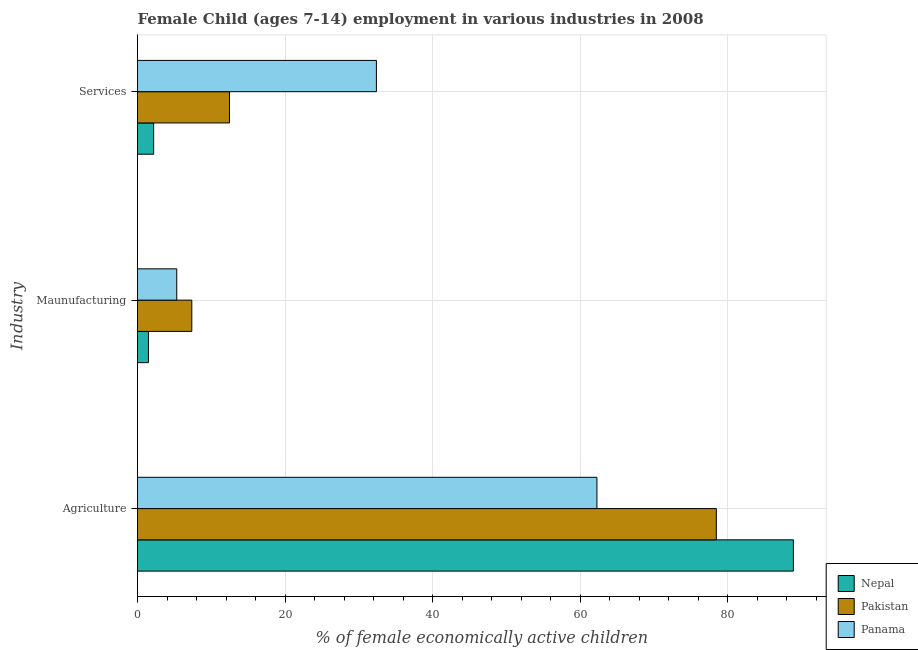How many different coloured bars are there?
Make the answer very short. 3. How many groups of bars are there?
Offer a very short reply. 3. Are the number of bars per tick equal to the number of legend labels?
Ensure brevity in your answer.  Yes. Are the number of bars on each tick of the Y-axis equal?
Give a very brief answer. Yes. How many bars are there on the 1st tick from the top?
Your answer should be very brief. 3. What is the label of the 1st group of bars from the top?
Provide a short and direct response. Services. What is the percentage of economically active children in manufacturing in Pakistan?
Keep it short and to the point. 7.36. Across all countries, what is the maximum percentage of economically active children in manufacturing?
Keep it short and to the point. 7.36. Across all countries, what is the minimum percentage of economically active children in manufacturing?
Give a very brief answer. 1.48. In which country was the percentage of economically active children in services minimum?
Make the answer very short. Nepal. What is the total percentage of economically active children in manufacturing in the graph?
Keep it short and to the point. 14.16. What is the difference between the percentage of economically active children in agriculture in Panama and that in Pakistan?
Offer a very short reply. -16.19. What is the difference between the percentage of economically active children in services in Nepal and the percentage of economically active children in agriculture in Pakistan?
Offer a terse response. -76.29. What is the average percentage of economically active children in services per country?
Offer a very short reply. 15.68. What is the difference between the percentage of economically active children in manufacturing and percentage of economically active children in agriculture in Panama?
Offer a terse response. -56.97. In how many countries, is the percentage of economically active children in manufacturing greater than 24 %?
Offer a very short reply. 0. What is the ratio of the percentage of economically active children in services in Panama to that in Nepal?
Provide a short and direct response. 14.79. Is the percentage of economically active children in agriculture in Pakistan less than that in Nepal?
Make the answer very short. Yes. Is the difference between the percentage of economically active children in services in Nepal and Pakistan greater than the difference between the percentage of economically active children in agriculture in Nepal and Pakistan?
Your response must be concise. No. What is the difference between the highest and the second highest percentage of economically active children in manufacturing?
Make the answer very short. 2.04. What is the difference between the highest and the lowest percentage of economically active children in services?
Your answer should be compact. 30.2. In how many countries, is the percentage of economically active children in services greater than the average percentage of economically active children in services taken over all countries?
Keep it short and to the point. 1. Is the sum of the percentage of economically active children in manufacturing in Panama and Nepal greater than the maximum percentage of economically active children in services across all countries?
Ensure brevity in your answer.  No. What does the 3rd bar from the top in Agriculture represents?
Keep it short and to the point. Nepal. What does the 1st bar from the bottom in Services represents?
Make the answer very short. Nepal. Are all the bars in the graph horizontal?
Offer a terse response. Yes. What is the difference between two consecutive major ticks on the X-axis?
Offer a very short reply. 20. Are the values on the major ticks of X-axis written in scientific E-notation?
Your answer should be very brief. No. Does the graph contain grids?
Your answer should be compact. Yes. What is the title of the graph?
Your response must be concise. Female Child (ages 7-14) employment in various industries in 2008. What is the label or title of the X-axis?
Provide a short and direct response. % of female economically active children. What is the label or title of the Y-axis?
Give a very brief answer. Industry. What is the % of female economically active children of Nepal in Agriculture?
Provide a succinct answer. 88.93. What is the % of female economically active children of Pakistan in Agriculture?
Offer a terse response. 78.48. What is the % of female economically active children in Panama in Agriculture?
Your response must be concise. 62.29. What is the % of female economically active children in Nepal in Maunufacturing?
Your answer should be very brief. 1.48. What is the % of female economically active children in Pakistan in Maunufacturing?
Provide a succinct answer. 7.36. What is the % of female economically active children in Panama in Maunufacturing?
Provide a succinct answer. 5.32. What is the % of female economically active children in Nepal in Services?
Your response must be concise. 2.19. What is the % of female economically active children in Pakistan in Services?
Give a very brief answer. 12.47. What is the % of female economically active children in Panama in Services?
Provide a succinct answer. 32.39. Across all Industry, what is the maximum % of female economically active children of Nepal?
Ensure brevity in your answer.  88.93. Across all Industry, what is the maximum % of female economically active children of Pakistan?
Provide a short and direct response. 78.48. Across all Industry, what is the maximum % of female economically active children in Panama?
Your response must be concise. 62.29. Across all Industry, what is the minimum % of female economically active children of Nepal?
Offer a terse response. 1.48. Across all Industry, what is the minimum % of female economically active children in Pakistan?
Ensure brevity in your answer.  7.36. Across all Industry, what is the minimum % of female economically active children in Panama?
Provide a succinct answer. 5.32. What is the total % of female economically active children of Nepal in the graph?
Make the answer very short. 92.6. What is the total % of female economically active children of Pakistan in the graph?
Ensure brevity in your answer.  98.31. What is the difference between the % of female economically active children of Nepal in Agriculture and that in Maunufacturing?
Ensure brevity in your answer.  87.45. What is the difference between the % of female economically active children in Pakistan in Agriculture and that in Maunufacturing?
Provide a succinct answer. 71.12. What is the difference between the % of female economically active children in Panama in Agriculture and that in Maunufacturing?
Ensure brevity in your answer.  56.97. What is the difference between the % of female economically active children in Nepal in Agriculture and that in Services?
Provide a succinct answer. 86.74. What is the difference between the % of female economically active children of Pakistan in Agriculture and that in Services?
Your answer should be compact. 66.01. What is the difference between the % of female economically active children of Panama in Agriculture and that in Services?
Ensure brevity in your answer.  29.9. What is the difference between the % of female economically active children of Nepal in Maunufacturing and that in Services?
Your answer should be very brief. -0.71. What is the difference between the % of female economically active children in Pakistan in Maunufacturing and that in Services?
Provide a succinct answer. -5.11. What is the difference between the % of female economically active children in Panama in Maunufacturing and that in Services?
Offer a very short reply. -27.07. What is the difference between the % of female economically active children in Nepal in Agriculture and the % of female economically active children in Pakistan in Maunufacturing?
Offer a terse response. 81.57. What is the difference between the % of female economically active children of Nepal in Agriculture and the % of female economically active children of Panama in Maunufacturing?
Your answer should be compact. 83.61. What is the difference between the % of female economically active children of Pakistan in Agriculture and the % of female economically active children of Panama in Maunufacturing?
Ensure brevity in your answer.  73.16. What is the difference between the % of female economically active children in Nepal in Agriculture and the % of female economically active children in Pakistan in Services?
Your answer should be very brief. 76.46. What is the difference between the % of female economically active children of Nepal in Agriculture and the % of female economically active children of Panama in Services?
Your response must be concise. 56.54. What is the difference between the % of female economically active children of Pakistan in Agriculture and the % of female economically active children of Panama in Services?
Ensure brevity in your answer.  46.09. What is the difference between the % of female economically active children of Nepal in Maunufacturing and the % of female economically active children of Pakistan in Services?
Provide a short and direct response. -10.99. What is the difference between the % of female economically active children in Nepal in Maunufacturing and the % of female economically active children in Panama in Services?
Your response must be concise. -30.91. What is the difference between the % of female economically active children in Pakistan in Maunufacturing and the % of female economically active children in Panama in Services?
Ensure brevity in your answer.  -25.03. What is the average % of female economically active children of Nepal per Industry?
Offer a very short reply. 30.87. What is the average % of female economically active children of Pakistan per Industry?
Give a very brief answer. 32.77. What is the average % of female economically active children in Panama per Industry?
Give a very brief answer. 33.33. What is the difference between the % of female economically active children in Nepal and % of female economically active children in Pakistan in Agriculture?
Your response must be concise. 10.45. What is the difference between the % of female economically active children of Nepal and % of female economically active children of Panama in Agriculture?
Your answer should be very brief. 26.64. What is the difference between the % of female economically active children of Pakistan and % of female economically active children of Panama in Agriculture?
Keep it short and to the point. 16.19. What is the difference between the % of female economically active children of Nepal and % of female economically active children of Pakistan in Maunufacturing?
Ensure brevity in your answer.  -5.88. What is the difference between the % of female economically active children of Nepal and % of female economically active children of Panama in Maunufacturing?
Make the answer very short. -3.84. What is the difference between the % of female economically active children of Pakistan and % of female economically active children of Panama in Maunufacturing?
Provide a short and direct response. 2.04. What is the difference between the % of female economically active children of Nepal and % of female economically active children of Pakistan in Services?
Your answer should be compact. -10.28. What is the difference between the % of female economically active children in Nepal and % of female economically active children in Panama in Services?
Keep it short and to the point. -30.2. What is the difference between the % of female economically active children in Pakistan and % of female economically active children in Panama in Services?
Provide a short and direct response. -19.92. What is the ratio of the % of female economically active children of Nepal in Agriculture to that in Maunufacturing?
Provide a short and direct response. 60.09. What is the ratio of the % of female economically active children of Pakistan in Agriculture to that in Maunufacturing?
Ensure brevity in your answer.  10.66. What is the ratio of the % of female economically active children in Panama in Agriculture to that in Maunufacturing?
Make the answer very short. 11.71. What is the ratio of the % of female economically active children of Nepal in Agriculture to that in Services?
Give a very brief answer. 40.61. What is the ratio of the % of female economically active children in Pakistan in Agriculture to that in Services?
Provide a short and direct response. 6.29. What is the ratio of the % of female economically active children of Panama in Agriculture to that in Services?
Ensure brevity in your answer.  1.92. What is the ratio of the % of female economically active children of Nepal in Maunufacturing to that in Services?
Make the answer very short. 0.68. What is the ratio of the % of female economically active children in Pakistan in Maunufacturing to that in Services?
Make the answer very short. 0.59. What is the ratio of the % of female economically active children in Panama in Maunufacturing to that in Services?
Give a very brief answer. 0.16. What is the difference between the highest and the second highest % of female economically active children in Nepal?
Offer a terse response. 86.74. What is the difference between the highest and the second highest % of female economically active children of Pakistan?
Your answer should be compact. 66.01. What is the difference between the highest and the second highest % of female economically active children in Panama?
Ensure brevity in your answer.  29.9. What is the difference between the highest and the lowest % of female economically active children of Nepal?
Keep it short and to the point. 87.45. What is the difference between the highest and the lowest % of female economically active children in Pakistan?
Ensure brevity in your answer.  71.12. What is the difference between the highest and the lowest % of female economically active children in Panama?
Give a very brief answer. 56.97. 